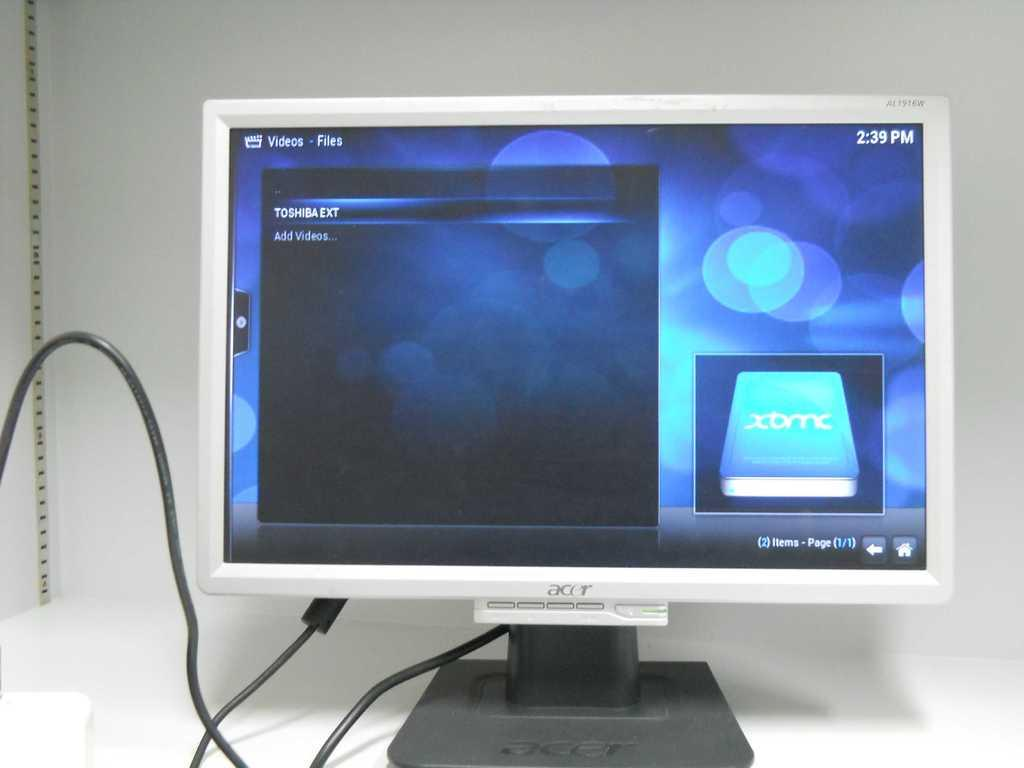<image>
Present a compact description of the photo's key features. A computer monitor displaying a Toshiba external hard drive's folders. 